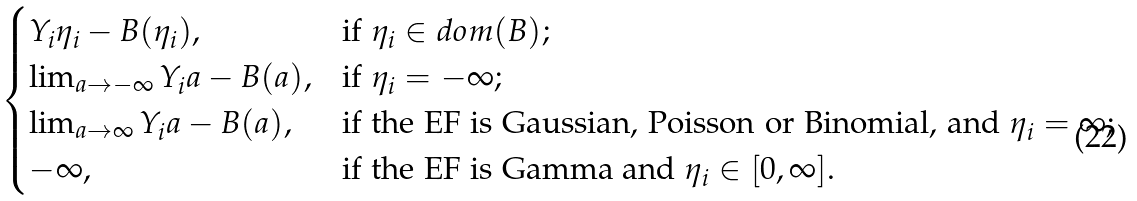<formula> <loc_0><loc_0><loc_500><loc_500>\begin{cases} Y _ { i } \eta _ { i } - B ( \eta _ { i } ) , & \text {if } \eta _ { i } \in d o m ( B ) ; \\ \lim _ { a \rightarrow - \infty } Y _ { i } a - B ( a ) , & \text {if } \eta _ { i } = - \infty ; \\ \lim _ { a \rightarrow \infty } Y _ { i } a - B ( a ) , & \text {if the EF is Gaussian, Poisson or Binomial, and } \eta _ { i } = \infty ; \\ - \infty , & \text {if the EF is Gamma and } \eta _ { i } \in [ 0 , \infty ] . \end{cases}</formula> 